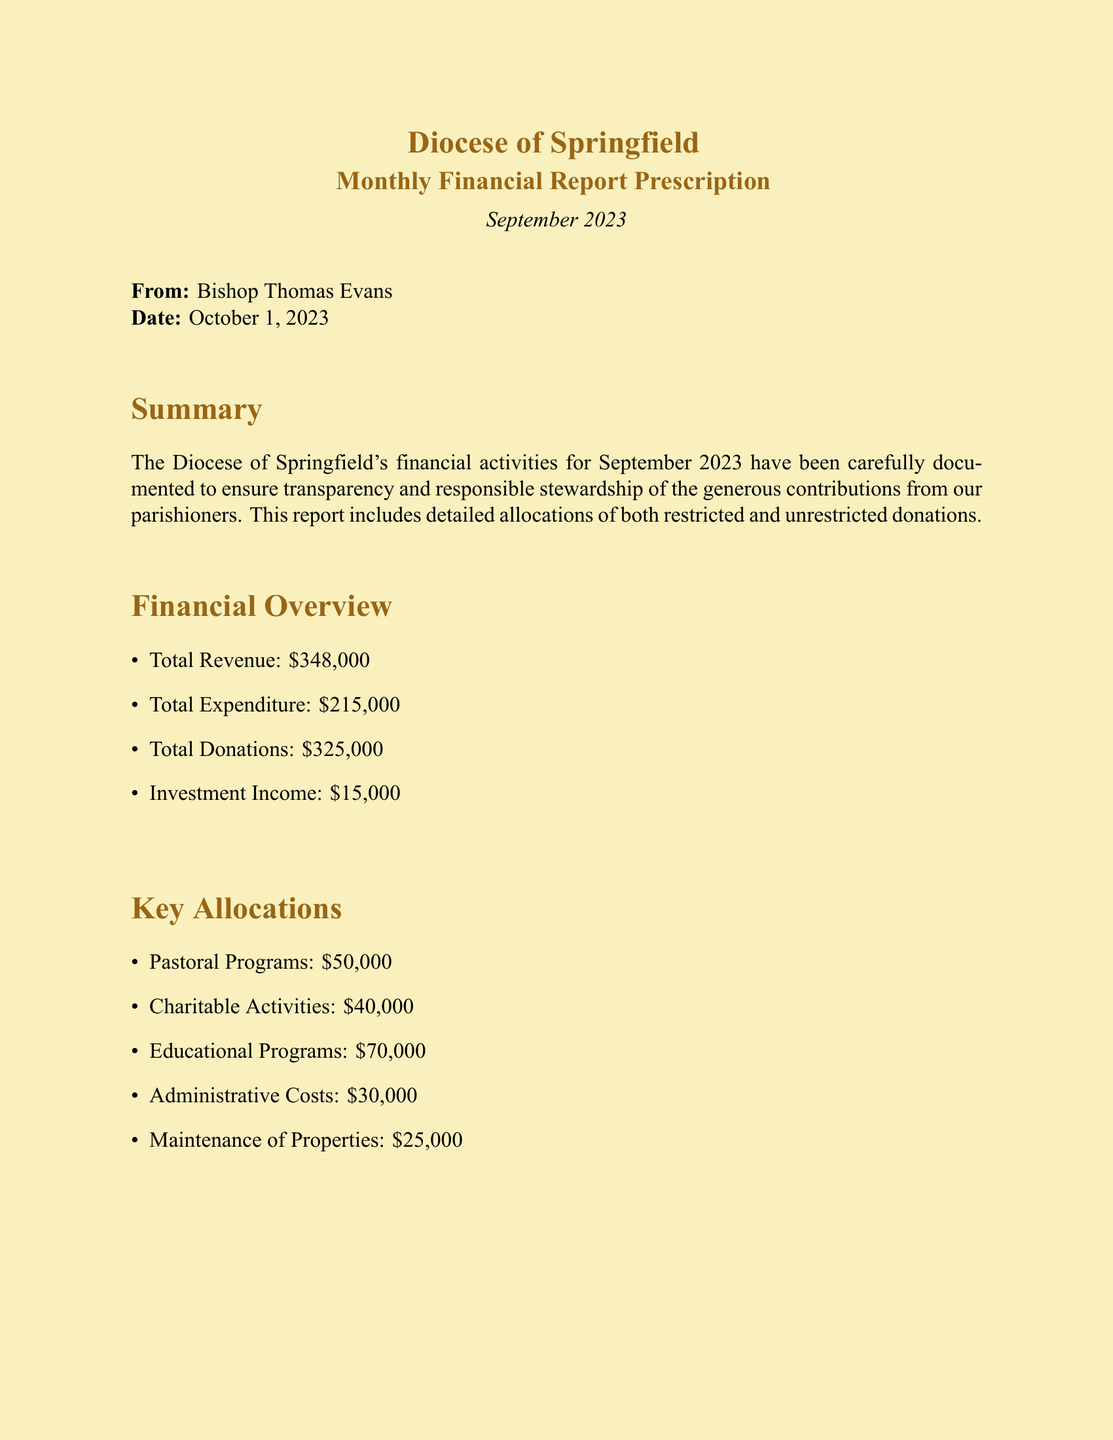What is the total revenue? The total revenue is stated in the financial overview section, which includes all sources of revenue.
Answer: $348,000 What was the total expenditure? The total expenditure is detailed in the financial overview, representing the total amount spent in September 2023.
Answer: $215,000 How much was allocated to educational programs? Educational programs are listed under key allocations with a specific amount for September 2023.
Answer: $70,000 What is the date of this report? The date of the report is mentioned at the beginning of the document, marking when it was written.
Answer: October 1, 2023 What percentage of total donations was allocated to charitable activities? To find the percentage, we can look at the total donations and specific allocations for charitable activities. Total donations are $325,000, and the allocation for charitable activities is $40,000. The calculation is ($40,000 ÷ $325,000) × 100, which represents the share of donations.
Answer: 12.31% What is recommended for maintaining administrative costs? The prescription section states recommendations aimed at achieving responsible spending, particularly regarding administrative costs.
Answer: Keep in check What is the investment income reported? The document specifies the investment income as part of the financial overview section, which includes additional revenue sources.
Answer: $15,000 Who is the author of this financial report? The report is introduced at the beginning with a signature at the end, indicating the responsible person.
Answer: Bishop Thomas Evans What are the key areas identified for the allocation of funds? The document lists key allocations in a structured format, highlighting specific areas that require funding.
Answer: Pastoral Programs, Charitable Activities, Educational Programs, Administrative Costs, Maintenance of Properties 